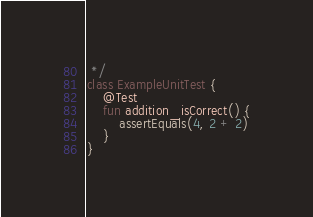<code> <loc_0><loc_0><loc_500><loc_500><_Kotlin_> */
class ExampleUnitTest {
    @Test
    fun addition_isCorrect() {
        assertEquals(4, 2 + 2)
    }
}</code> 